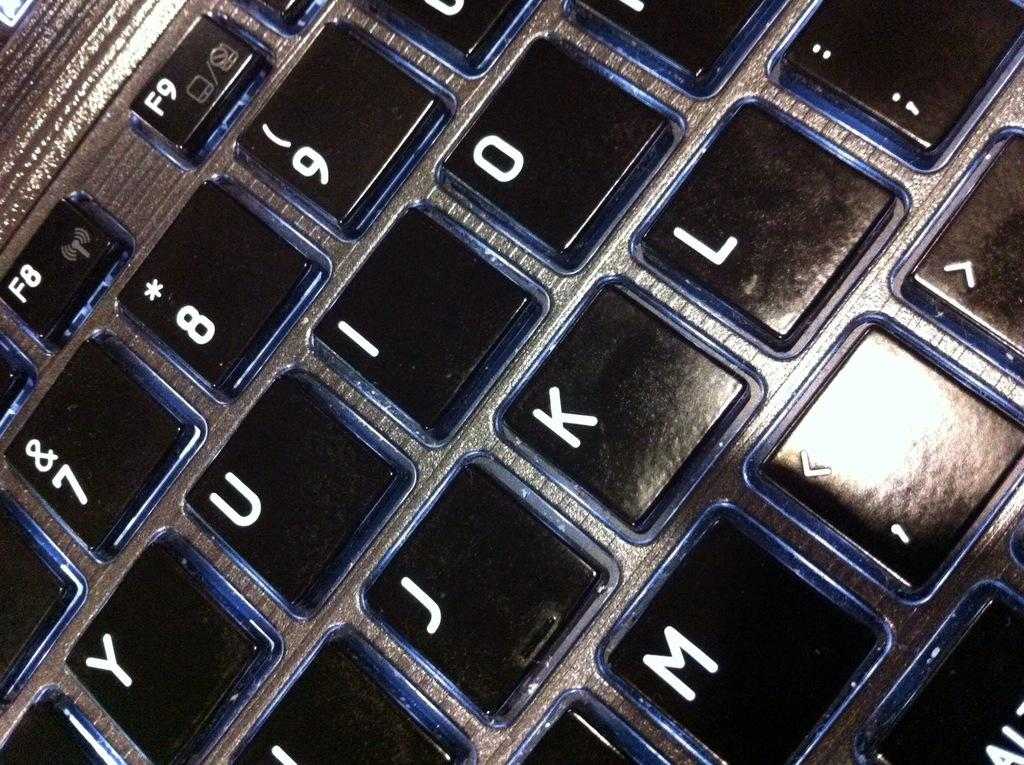<image>
Render a clear and concise summary of the photo. Black keyboard with the letter K between the J and L keys. 